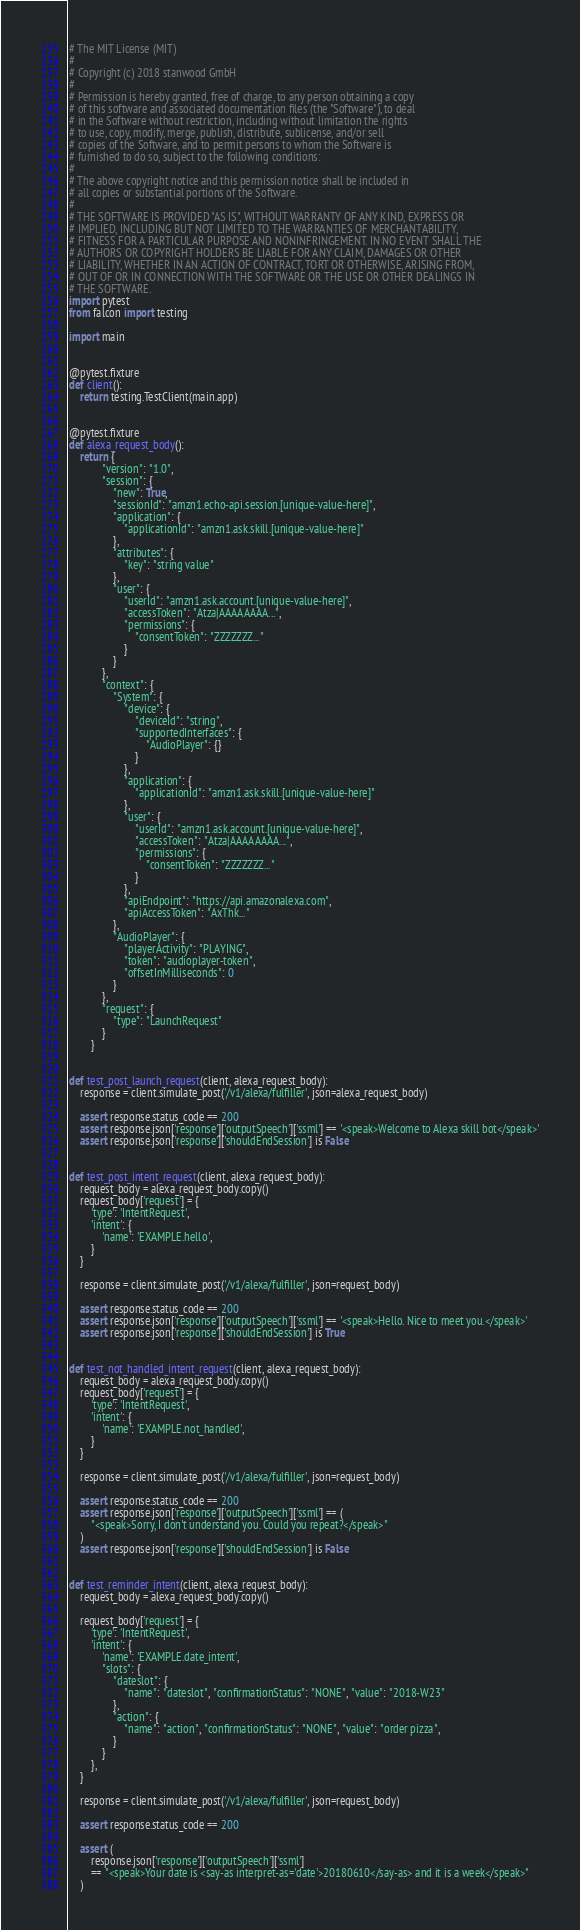<code> <loc_0><loc_0><loc_500><loc_500><_Python_># The MIT License (MIT)
# 
# Copyright (c) 2018 stanwood GmbH
# 
# Permission is hereby granted, free of charge, to any person obtaining a copy
# of this software and associated documentation files (the "Software"), to deal
# in the Software without restriction, including without limitation the rights
# to use, copy, modify, merge, publish, distribute, sublicense, and/or sell
# copies of the Software, and to permit persons to whom the Software is
# furnished to do so, subject to the following conditions:
# 
# The above copyright notice and this permission notice shall be included in
# all copies or substantial portions of the Software.
# 
# THE SOFTWARE IS PROVIDED "AS IS", WITHOUT WARRANTY OF ANY KIND, EXPRESS OR
# IMPLIED, INCLUDING BUT NOT LIMITED TO THE WARRANTIES OF MERCHANTABILITY,
# FITNESS FOR A PARTICULAR PURPOSE AND NONINFRINGEMENT. IN NO EVENT SHALL THE
# AUTHORS OR COPYRIGHT HOLDERS BE LIABLE FOR ANY CLAIM, DAMAGES OR OTHER
# LIABILITY, WHETHER IN AN ACTION OF CONTRACT, TORT OR OTHERWISE, ARISING FROM,
# OUT OF OR IN CONNECTION WITH THE SOFTWARE OR THE USE OR OTHER DEALINGS IN
# THE SOFTWARE.
import pytest
from falcon import testing

import main


@pytest.fixture
def client():
    return testing.TestClient(main.app)


@pytest.fixture
def alexa_request_body():
    return {
            "version": "1.0",
            "session": {
                "new": True,
                "sessionId": "amzn1.echo-api.session.[unique-value-here]",
                "application": {
                    "applicationId": "amzn1.ask.skill.[unique-value-here]"
                },
                "attributes": {
                    "key": "string value"
                },
                "user": {
                    "userId": "amzn1.ask.account.[unique-value-here]",
                    "accessToken": "Atza|AAAAAAAA...",
                    "permissions": {
                        "consentToken": "ZZZZZZZ..."
                    }
                }
            },
            "context": {
                "System": {
                    "device": {
                        "deviceId": "string",
                        "supportedInterfaces": {
                            "AudioPlayer": {}
                        }
                    },
                    "application": {
                        "applicationId": "amzn1.ask.skill.[unique-value-here]"
                    },
                    "user": {
                        "userId": "amzn1.ask.account.[unique-value-here]",
                        "accessToken": "Atza|AAAAAAAA...",
                        "permissions": {
                            "consentToken": "ZZZZZZZ..."
                        }
                    },
                    "apiEndpoint": "https://api.amazonalexa.com",
                    "apiAccessToken": "AxThk..."
                },
                "AudioPlayer": {
                    "playerActivity": "PLAYING",
                    "token": "audioplayer-token",
                    "offsetInMilliseconds": 0
                }
            },
            "request": {
                "type": "LaunchRequest"
            }
        }


def test_post_launch_request(client, alexa_request_body):
    response = client.simulate_post('/v1/alexa/fulfiller', json=alexa_request_body)

    assert response.status_code == 200
    assert response.json['response']['outputSpeech']['ssml'] == '<speak>Welcome to Alexa skill bot</speak>'
    assert response.json['response']['shouldEndSession'] is False


def test_post_intent_request(client, alexa_request_body):
    request_body = alexa_request_body.copy()
    request_body['request'] = {
        'type': 'IntentRequest',
        'intent': {
            'name': 'EXAMPLE.hello',
        }
    }

    response = client.simulate_post('/v1/alexa/fulfiller', json=request_body)

    assert response.status_code == 200
    assert response.json['response']['outputSpeech']['ssml'] == '<speak>Hello. Nice to meet you.</speak>'
    assert response.json['response']['shouldEndSession'] is True


def test_not_handled_intent_request(client, alexa_request_body):
    request_body = alexa_request_body.copy()
    request_body['request'] = {
        'type': 'IntentRequest',
        'intent': {
            'name': 'EXAMPLE.not_handled',
        }
    }

    response = client.simulate_post('/v1/alexa/fulfiller', json=request_body)

    assert response.status_code == 200
    assert response.json['response']['outputSpeech']['ssml'] == (
        "<speak>Sorry, I don't understand you. Could you repeat?</speak>"
    )
    assert response.json['response']['shouldEndSession'] is False


def test_reminder_intent(client, alexa_request_body):
    request_body = alexa_request_body.copy()

    request_body['request'] = {
        'type': 'IntentRequest',
        'intent': {
            'name': 'EXAMPLE.date_intent',
            "slots": {
                "dateslot": {
                    "name": "dateslot", "confirmationStatus": "NONE", "value": "2018-W23"
                },
                "action": {
                    "name": "action", "confirmationStatus": "NONE", "value": "order pizza",
                }
            }
        },
    }

    response = client.simulate_post('/v1/alexa/fulfiller', json=request_body)

    assert response.status_code == 200

    assert (
        response.json['response']['outputSpeech']['ssml']
        == "<speak>Your date is <say-as interpret-as='date'>20180610</say-as> and it is a week</speak>"
    )</code> 